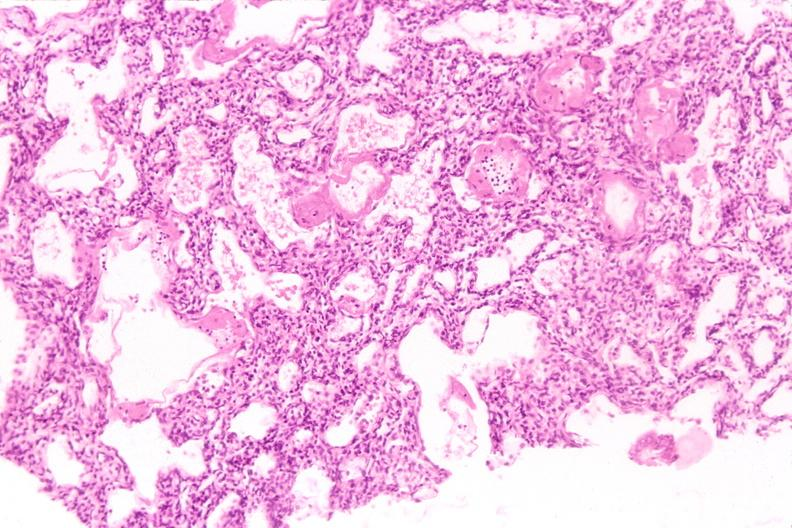what does this image show?
Answer the question using a single word or phrase. Lungs 